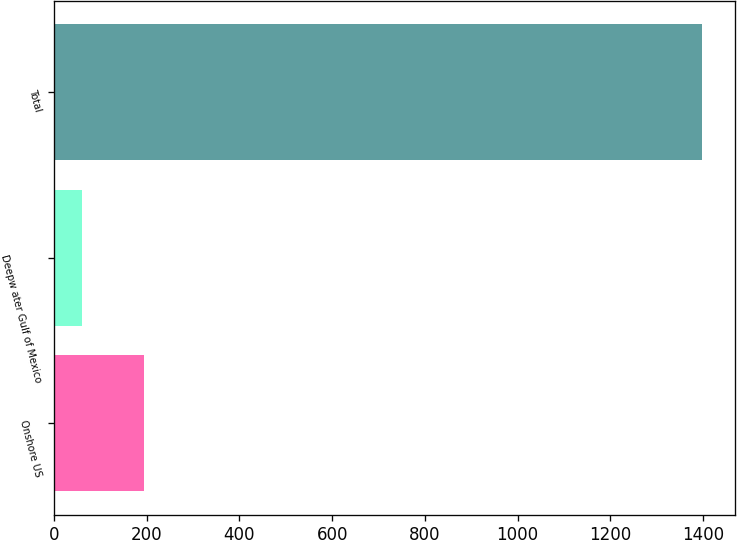Convert chart. <chart><loc_0><loc_0><loc_500><loc_500><bar_chart><fcel>Onshore US<fcel>Deepw ater Gulf of Mexico<fcel>Total<nl><fcel>193.9<fcel>60<fcel>1399<nl></chart> 